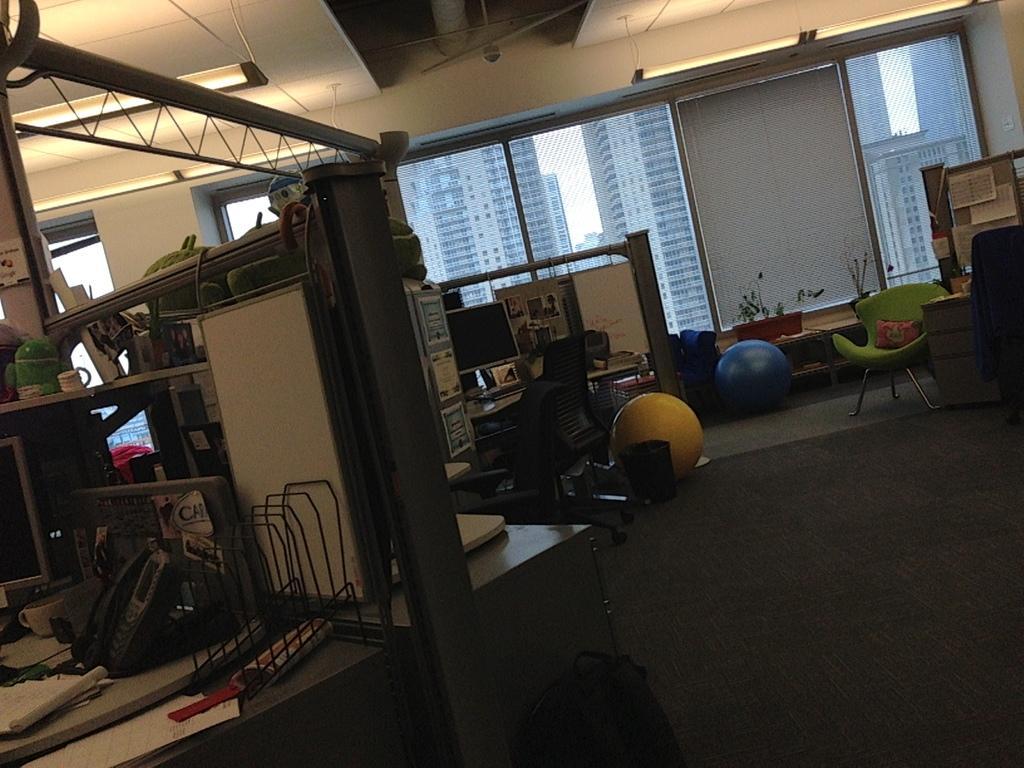How would you summarize this image in a sentence or two? In this image I can see some objects on the table. I can see some objects on the floor. In the background, I can see the buildings. At the top I can see the lights. 